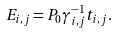Convert formula to latex. <formula><loc_0><loc_0><loc_500><loc_500>E _ { i , j } = P _ { 0 } \gamma _ { i , j } ^ { - 1 } t _ { i , j } .</formula> 